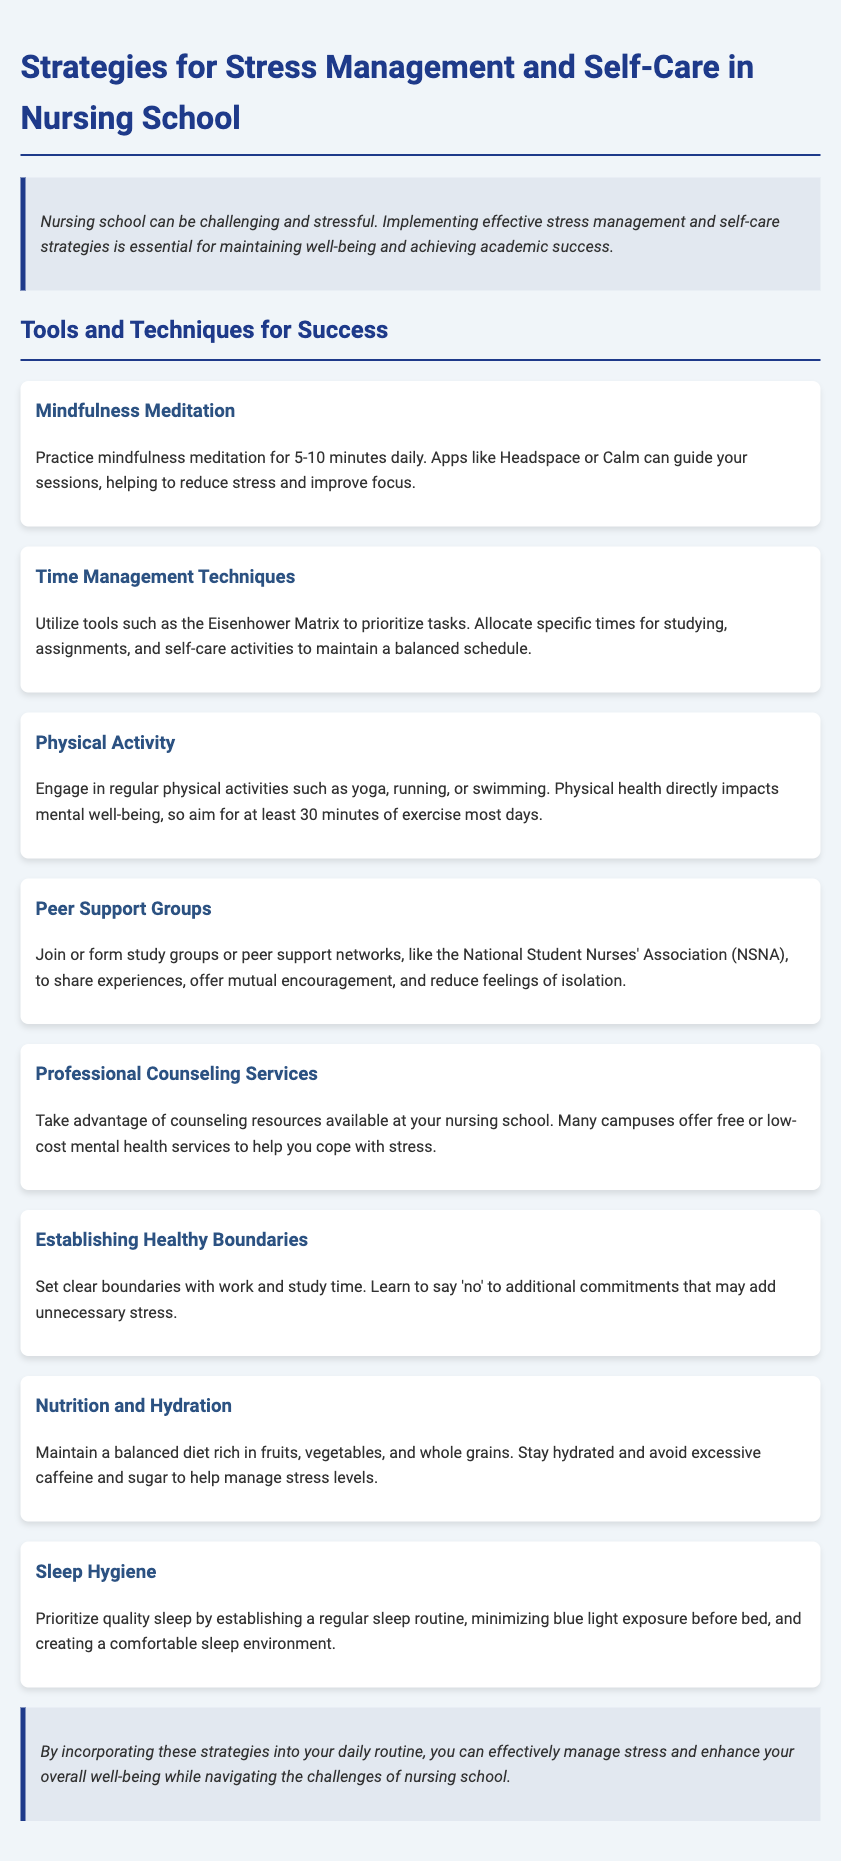What is the main focus of the document? The main focus of the document is to provide strategies for nursing students to manage stress and practice self-care.
Answer: Stress management and self-care How long should mindfulness meditation be practiced daily? The document specifies the duration of mindfulness meditation practice recommended for nursing students.
Answer: 5-10 minutes What activity does the document suggest for physical health? The document mentions specific physical activities to engage in for mental well-being.
Answer: Yoga, running, or swimming Which group does the document recommend joining for peer support? It specifies an organization that nursing students can join or form for mutual encouragement.
Answer: National Student Nurses' Association (NSNA) What type of services are available for professional counseling? The document indicates that certain services are offered at nursing schools to help cope with stress.
Answer: Free or low-cost mental health services How can students manage their sleep hygiene according to the document? The document recommends specific actions to establish a sleep routine for quality sleep.
Answer: Establishing a regular sleep routine Why is it important to maintain good nutrition and hydration? The document connects nutrition and hydration to managing stress levels for nursing students.
Answer: Manage stress levels What is one technique mentioned for time management? The document provides a specific method for prioritizing tasks effectively.
Answer: Eisenhower Matrix 